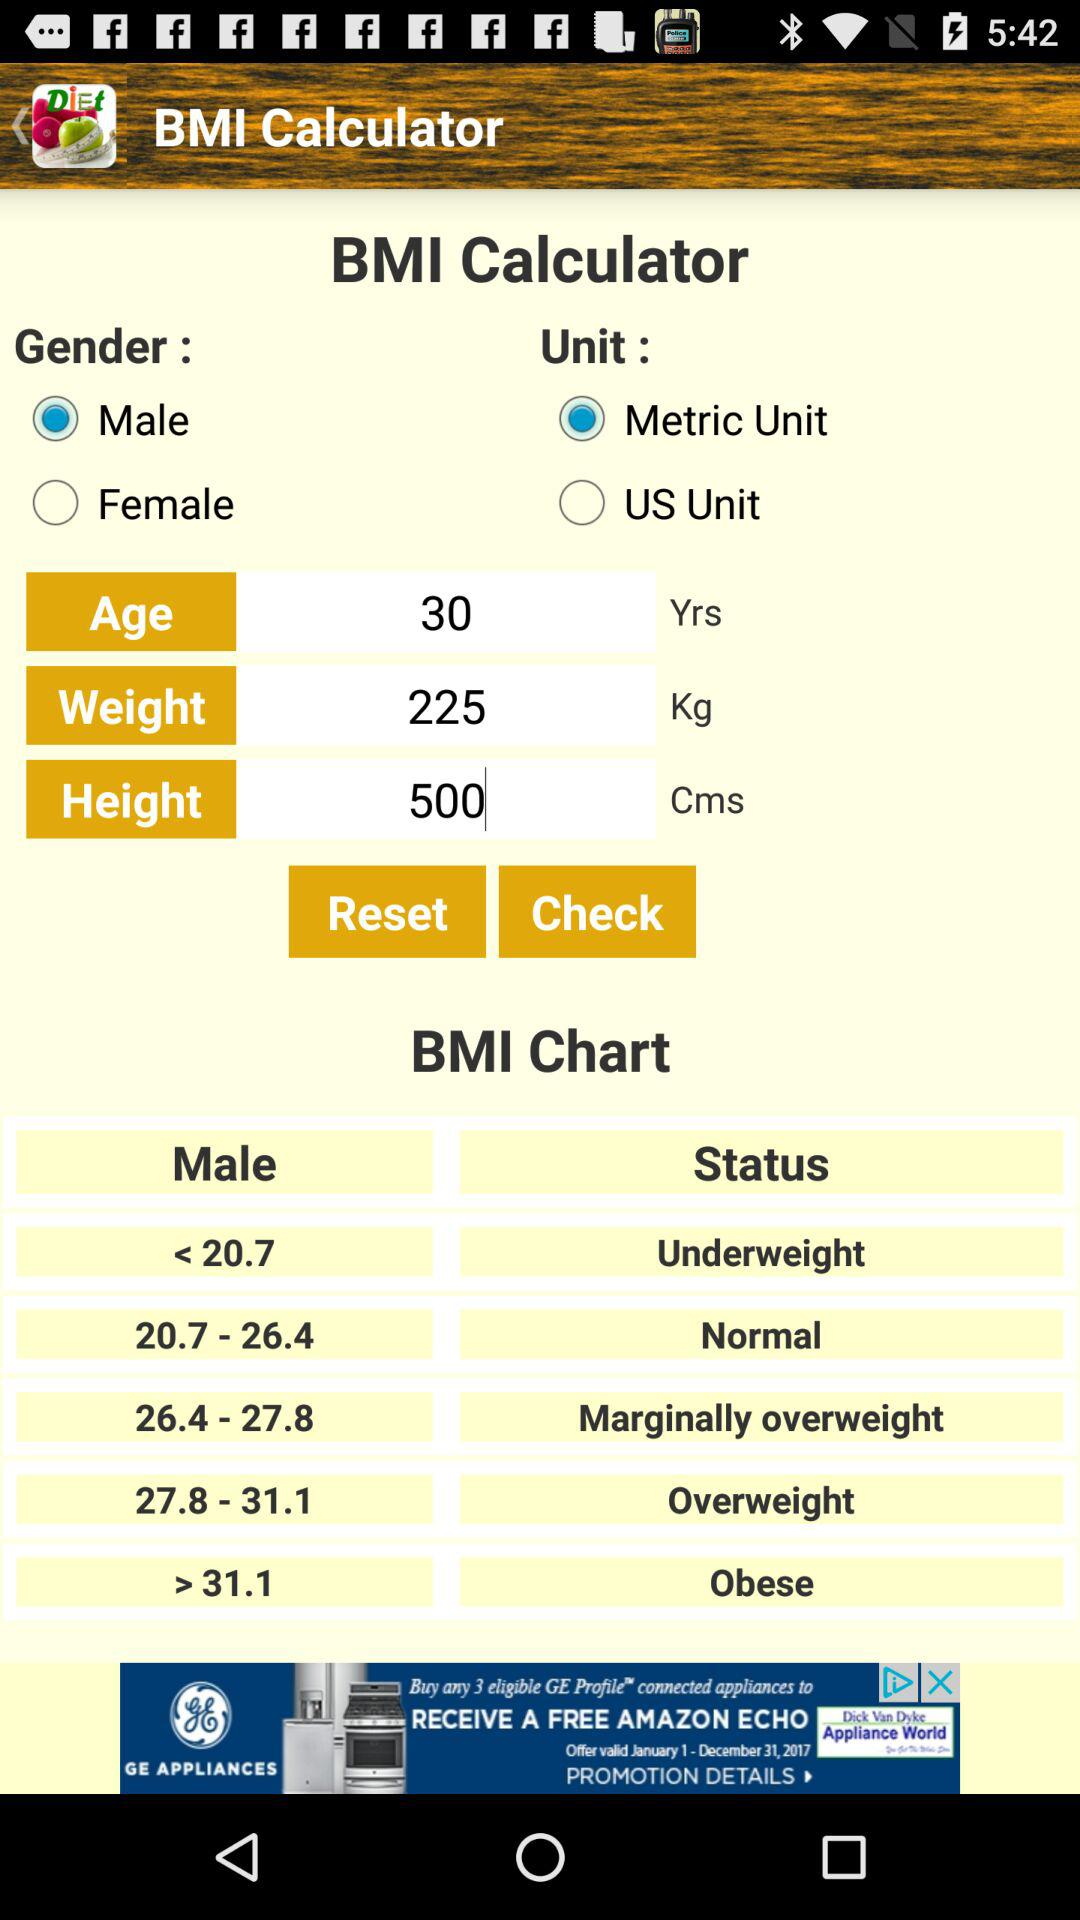Which type of unit is selected? The selected type of unit is metric. 